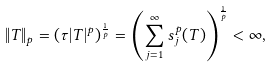Convert formula to latex. <formula><loc_0><loc_0><loc_500><loc_500>\| T \| _ { p } = ( \tau | T | ^ { p } ) ^ { \frac { 1 } { p } } = \left ( \sum _ { j = 1 } ^ { \infty } s _ { j } ^ { p } ( T ) \right ) ^ { \frac { 1 } { p } } < \infty ,</formula> 